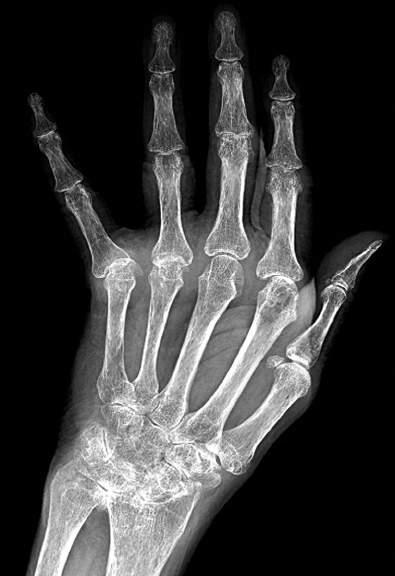what include diffuse osteopenia, marked loss of the joint spaces of the carpal, metacarpal, phalangeal, and interphalangeal joints, periarticular bony erosions, and ulnar drift of the fingers?
Answer the question using a single word or phrase. Characteristic features of rheumatoid arthritis 